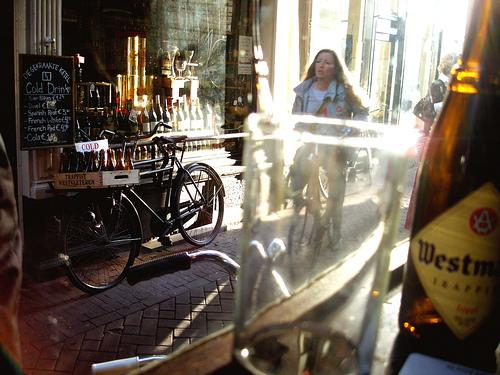This store likely sells what? Please explain your reasoning. beer. The sign refers to cold drinks. alcohol bottles are present. 